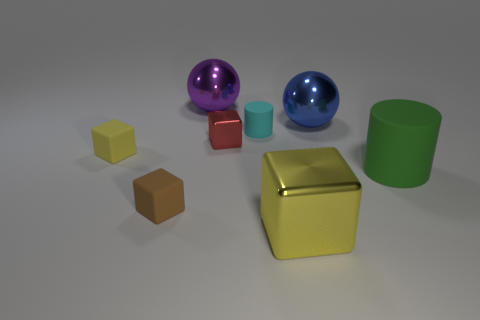Subtract all yellow blocks. How many were subtracted if there are1yellow blocks left? 1 Add 1 yellow matte things. How many objects exist? 9 Subtract all tiny metallic blocks. How many blocks are left? 3 Add 7 large shiny objects. How many large shiny objects exist? 10 Subtract all cyan cylinders. How many cylinders are left? 1 Subtract 1 red cubes. How many objects are left? 7 Subtract all spheres. How many objects are left? 6 Subtract 3 cubes. How many cubes are left? 1 Subtract all red blocks. Subtract all yellow spheres. How many blocks are left? 3 Subtract all green balls. How many yellow blocks are left? 2 